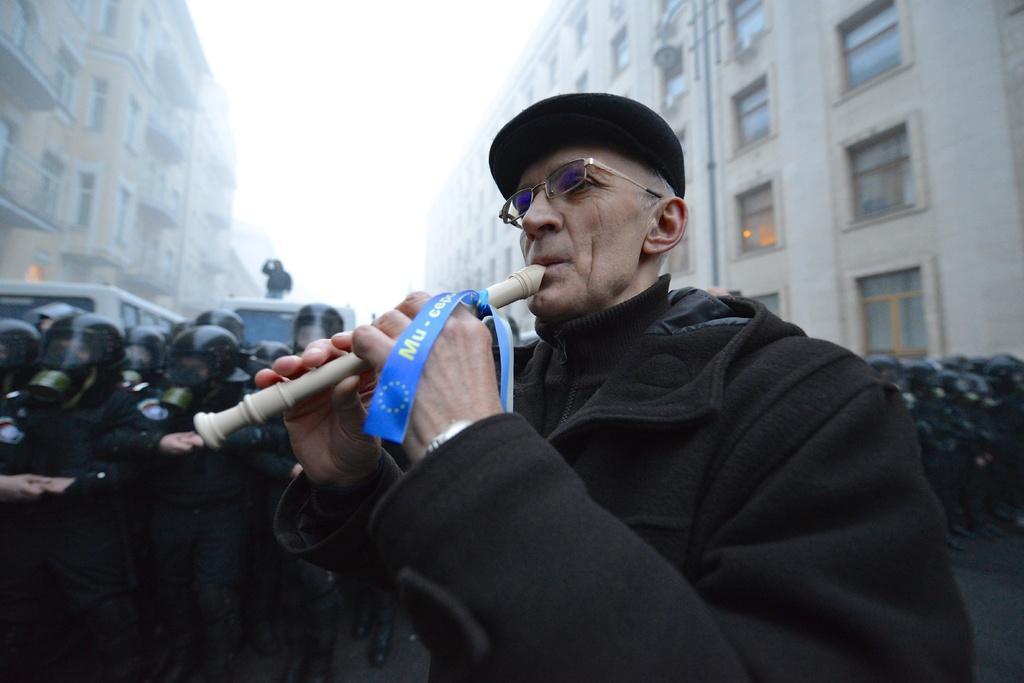In one or two sentences, can you explain what this image depicts? This image is taken outdoors. In the background there are two buildings with walls, windows, doors and rooms. At the top of the image there is the sky. In the background a few people are standing and two vehicles are parked on the road. In the middle of the image a man is standing and he is holding an object in his hands and kept in his mouth. 